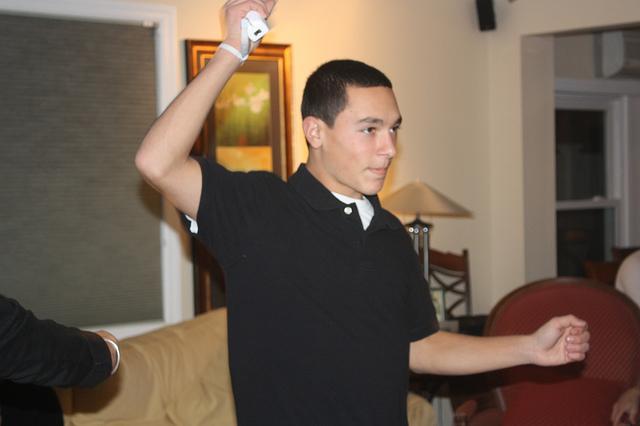What is in the picture?
Answer briefly. Man. Can part of another person be seen in this picture?
Answer briefly. Yes. What is in the guys right hand?
Concise answer only. Wii controller. Is the man wearing glasses?
Write a very short answer. No. What gesture is the hand making?
Concise answer only. Swinging. What gaming system is the guy playing?
Write a very short answer. Wii. 